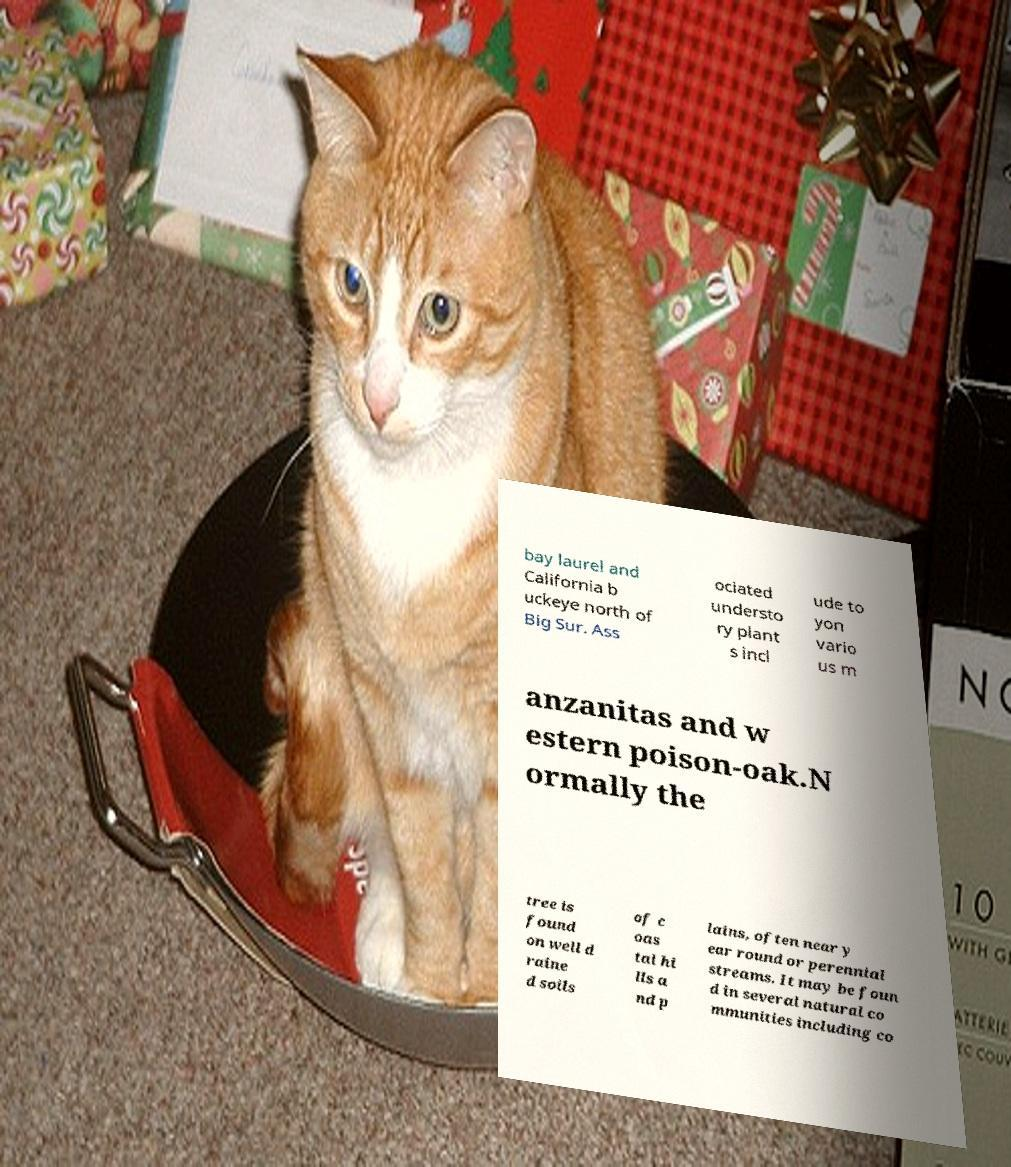Please read and relay the text visible in this image. What does it say? bay laurel and California b uckeye north of Big Sur. Ass ociated understo ry plant s incl ude to yon vario us m anzanitas and w estern poison-oak.N ormally the tree is found on well d raine d soils of c oas tal hi lls a nd p lains, often near y ear round or perennial streams. It may be foun d in several natural co mmunities including co 